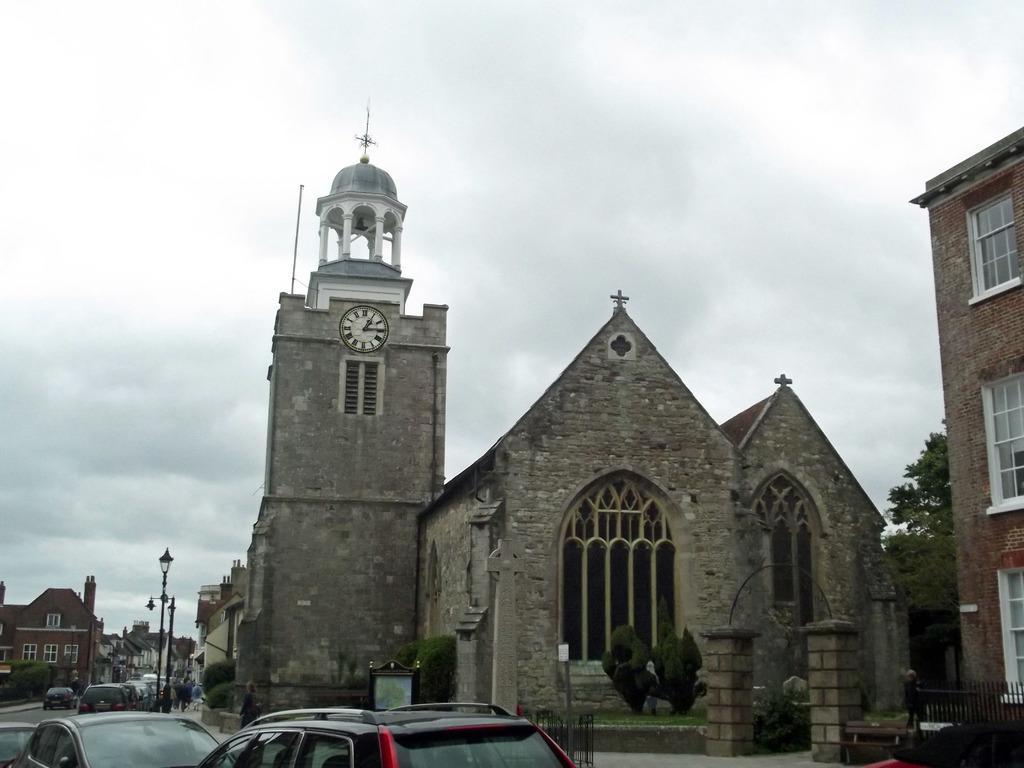Could you give a brief overview of what you see in this image? In this image I can see few buildings, in front I can see a clock tower. I can also see few vehicles on the road, light poles, and sky in white and gray color. 